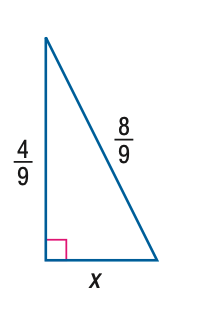Question: Find x.
Choices:
A. \frac { 4 } { 9 }
B. \frac { 4 } { 9 } \sqrt { 2 }
C. \frac { 4 } { 9 } \sqrt { 3 }
D. \frac { 4 } { 9 } \sqrt { 5 }
Answer with the letter. Answer: C 